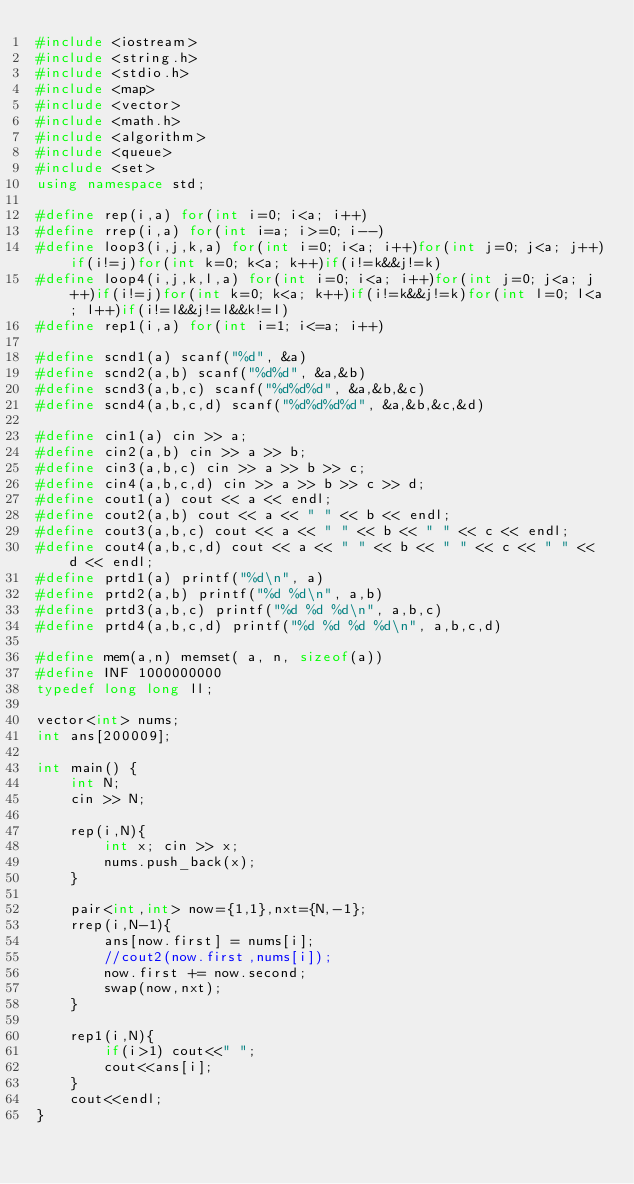Convert code to text. <code><loc_0><loc_0><loc_500><loc_500><_C++_>#include <iostream>
#include <string.h>
#include <stdio.h>
#include <map>
#include <vector>
#include <math.h>
#include <algorithm>
#include <queue>
#include <set>
using namespace std;

#define rep(i,a) for(int i=0; i<a; i++)
#define rrep(i,a) for(int i=a; i>=0; i--)
#define loop3(i,j,k,a) for(int i=0; i<a; i++)for(int j=0; j<a; j++)if(i!=j)for(int k=0; k<a; k++)if(i!=k&&j!=k)
#define loop4(i,j,k,l,a) for(int i=0; i<a; i++)for(int j=0; j<a; j++)if(i!=j)for(int k=0; k<a; k++)if(i!=k&&j!=k)for(int l=0; l<a; l++)if(i!=l&&j!=l&&k!=l)
#define rep1(i,a) for(int i=1; i<=a; i++)

#define scnd1(a) scanf("%d", &a)
#define scnd2(a,b) scanf("%d%d", &a,&b)
#define scnd3(a,b,c) scanf("%d%d%d", &a,&b,&c)
#define scnd4(a,b,c,d) scanf("%d%d%d%d", &a,&b,&c,&d)

#define cin1(a) cin >> a;
#define cin2(a,b) cin >> a >> b;
#define cin3(a,b,c) cin >> a >> b >> c;
#define cin4(a,b,c,d) cin >> a >> b >> c >> d;
#define cout1(a) cout << a << endl;
#define cout2(a,b) cout << a << " " << b << endl;
#define cout3(a,b,c) cout << a << " " << b << " " << c << endl;
#define cout4(a,b,c,d) cout << a << " " << b << " " << c << " " << d << endl;
#define prtd1(a) printf("%d\n", a)
#define prtd2(a,b) printf("%d %d\n", a,b)
#define prtd3(a,b,c) printf("%d %d %d\n", a,b,c)
#define prtd4(a,b,c,d) printf("%d %d %d %d\n", a,b,c,d)

#define mem(a,n) memset( a, n, sizeof(a))
#define INF 1000000000
typedef long long ll;

vector<int> nums;
int ans[200009];

int main() {
    int N;
    cin >> N;
    
    rep(i,N){
        int x; cin >> x;
        nums.push_back(x);
    }
    
    pair<int,int> now={1,1},nxt={N,-1};
    rrep(i,N-1){
        ans[now.first] = nums[i];
        //cout2(now.first,nums[i]);
        now.first += now.second;
        swap(now,nxt);
    }
    
    rep1(i,N){
        if(i>1) cout<<" ";
        cout<<ans[i];
    }
    cout<<endl;
}
</code> 